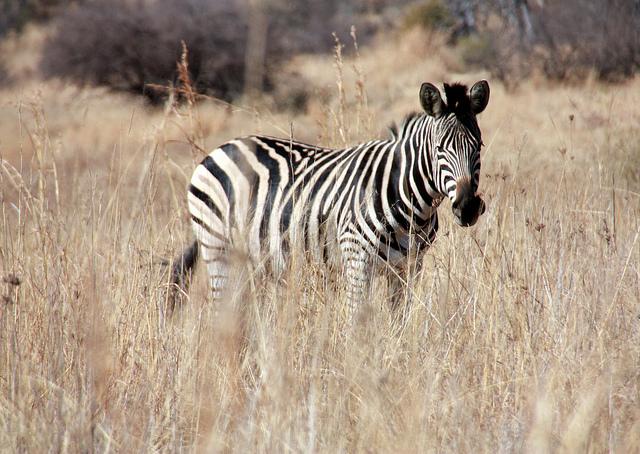Is the grass green?
Concise answer only. No. What other animal closely resembles these?
Short answer required. Horse. Is the animal in its natural habitat?
Short answer required. Yes. Is the animal looking at the camera?
Be succinct. Yes. Is there a bird flying on top of the zebra?
Quick response, please. No. 